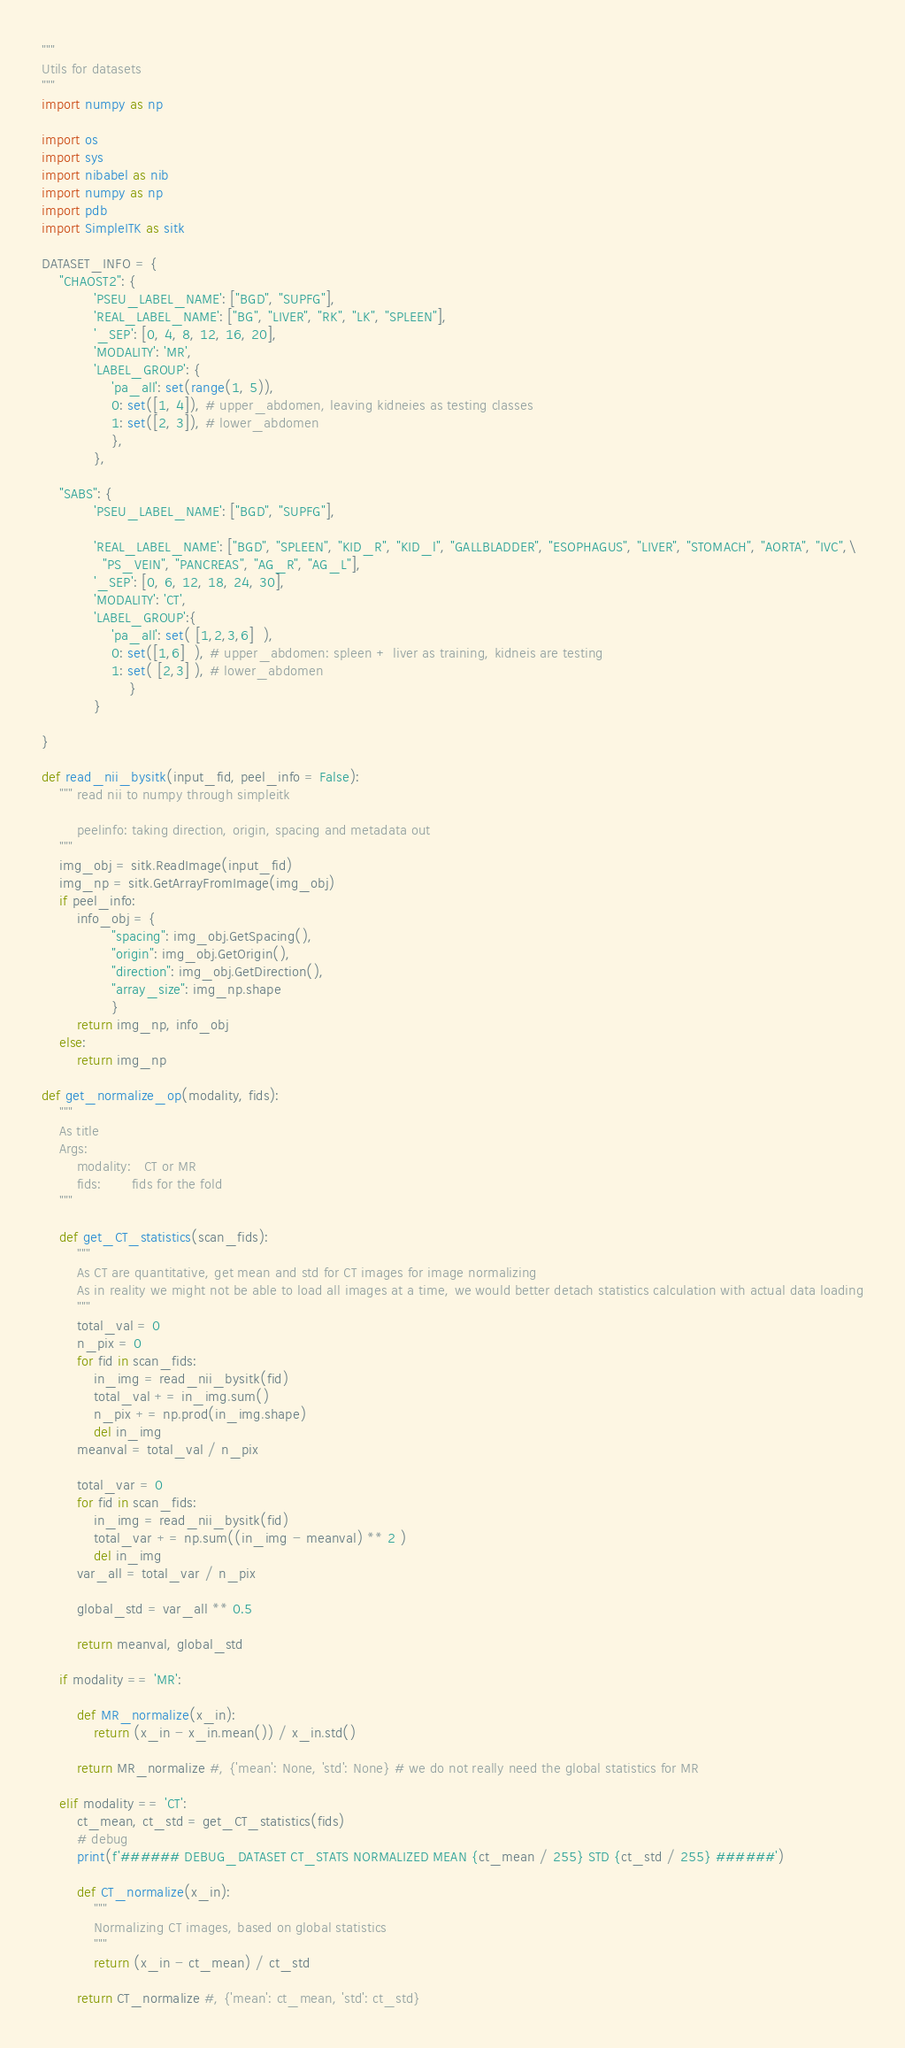Convert code to text. <code><loc_0><loc_0><loc_500><loc_500><_Python_>"""
Utils for datasets
"""
import numpy as np

import os
import sys
import nibabel as nib
import numpy as np
import pdb
import SimpleITK as sitk

DATASET_INFO = {
    "CHAOST2": {
            'PSEU_LABEL_NAME': ["BGD", "SUPFG"],
            'REAL_LABEL_NAME': ["BG", "LIVER", "RK", "LK", "SPLEEN"],
            '_SEP': [0, 4, 8, 12, 16, 20],
            'MODALITY': 'MR',
            'LABEL_GROUP': {
                'pa_all': set(range(1, 5)),
                0: set([1, 4]), # upper_abdomen, leaving kidneies as testing classes
                1: set([2, 3]), # lower_abdomen
                },
            },

    "SABS": {
            'PSEU_LABEL_NAME': ["BGD", "SUPFG"],

            'REAL_LABEL_NAME': ["BGD", "SPLEEN", "KID_R", "KID_l", "GALLBLADDER", "ESOPHAGUS", "LIVER", "STOMACH", "AORTA", "IVC",\
              "PS_VEIN", "PANCREAS", "AG_R", "AG_L"],
            '_SEP': [0, 6, 12, 18, 24, 30],
            'MODALITY': 'CT',
            'LABEL_GROUP':{
                'pa_all': set( [1,2,3,6]  ),
                0: set([1,6]  ), # upper_abdomen: spleen + liver as training, kidneis are testing
                1: set( [2,3] ), # lower_abdomen
                    }
            }

}

def read_nii_bysitk(input_fid, peel_info = False):
    """ read nii to numpy through simpleitk

        peelinfo: taking direction, origin, spacing and metadata out
    """
    img_obj = sitk.ReadImage(input_fid)
    img_np = sitk.GetArrayFromImage(img_obj)
    if peel_info:
        info_obj = {
                "spacing": img_obj.GetSpacing(),
                "origin": img_obj.GetOrigin(),
                "direction": img_obj.GetDirection(),
                "array_size": img_np.shape
                }
        return img_np, info_obj
    else:
        return img_np

def get_normalize_op(modality, fids):
    """
    As title
    Args:
        modality:   CT or MR
        fids:       fids for the fold
    """

    def get_CT_statistics(scan_fids):
        """
        As CT are quantitative, get mean and std for CT images for image normalizing
        As in reality we might not be able to load all images at a time, we would better detach statistics calculation with actual data loading
        """
        total_val = 0
        n_pix = 0
        for fid in scan_fids:
            in_img = read_nii_bysitk(fid)
            total_val += in_img.sum()
            n_pix += np.prod(in_img.shape)
            del in_img
        meanval = total_val / n_pix

        total_var = 0
        for fid in scan_fids:
            in_img = read_nii_bysitk(fid)
            total_var += np.sum((in_img - meanval) ** 2 )
            del in_img
        var_all = total_var / n_pix

        global_std = var_all ** 0.5

        return meanval, global_std

    if modality == 'MR':

        def MR_normalize(x_in):
            return (x_in - x_in.mean()) / x_in.std()

        return MR_normalize #, {'mean': None, 'std': None} # we do not really need the global statistics for MR

    elif modality == 'CT':
        ct_mean, ct_std = get_CT_statistics(fids)
        # debug
        print(f'###### DEBUG_DATASET CT_STATS NORMALIZED MEAN {ct_mean / 255} STD {ct_std / 255} ######')

        def CT_normalize(x_in):
            """
            Normalizing CT images, based on global statistics
            """
            return (x_in - ct_mean) / ct_std

        return CT_normalize #, {'mean': ct_mean, 'std': ct_std}


</code> 